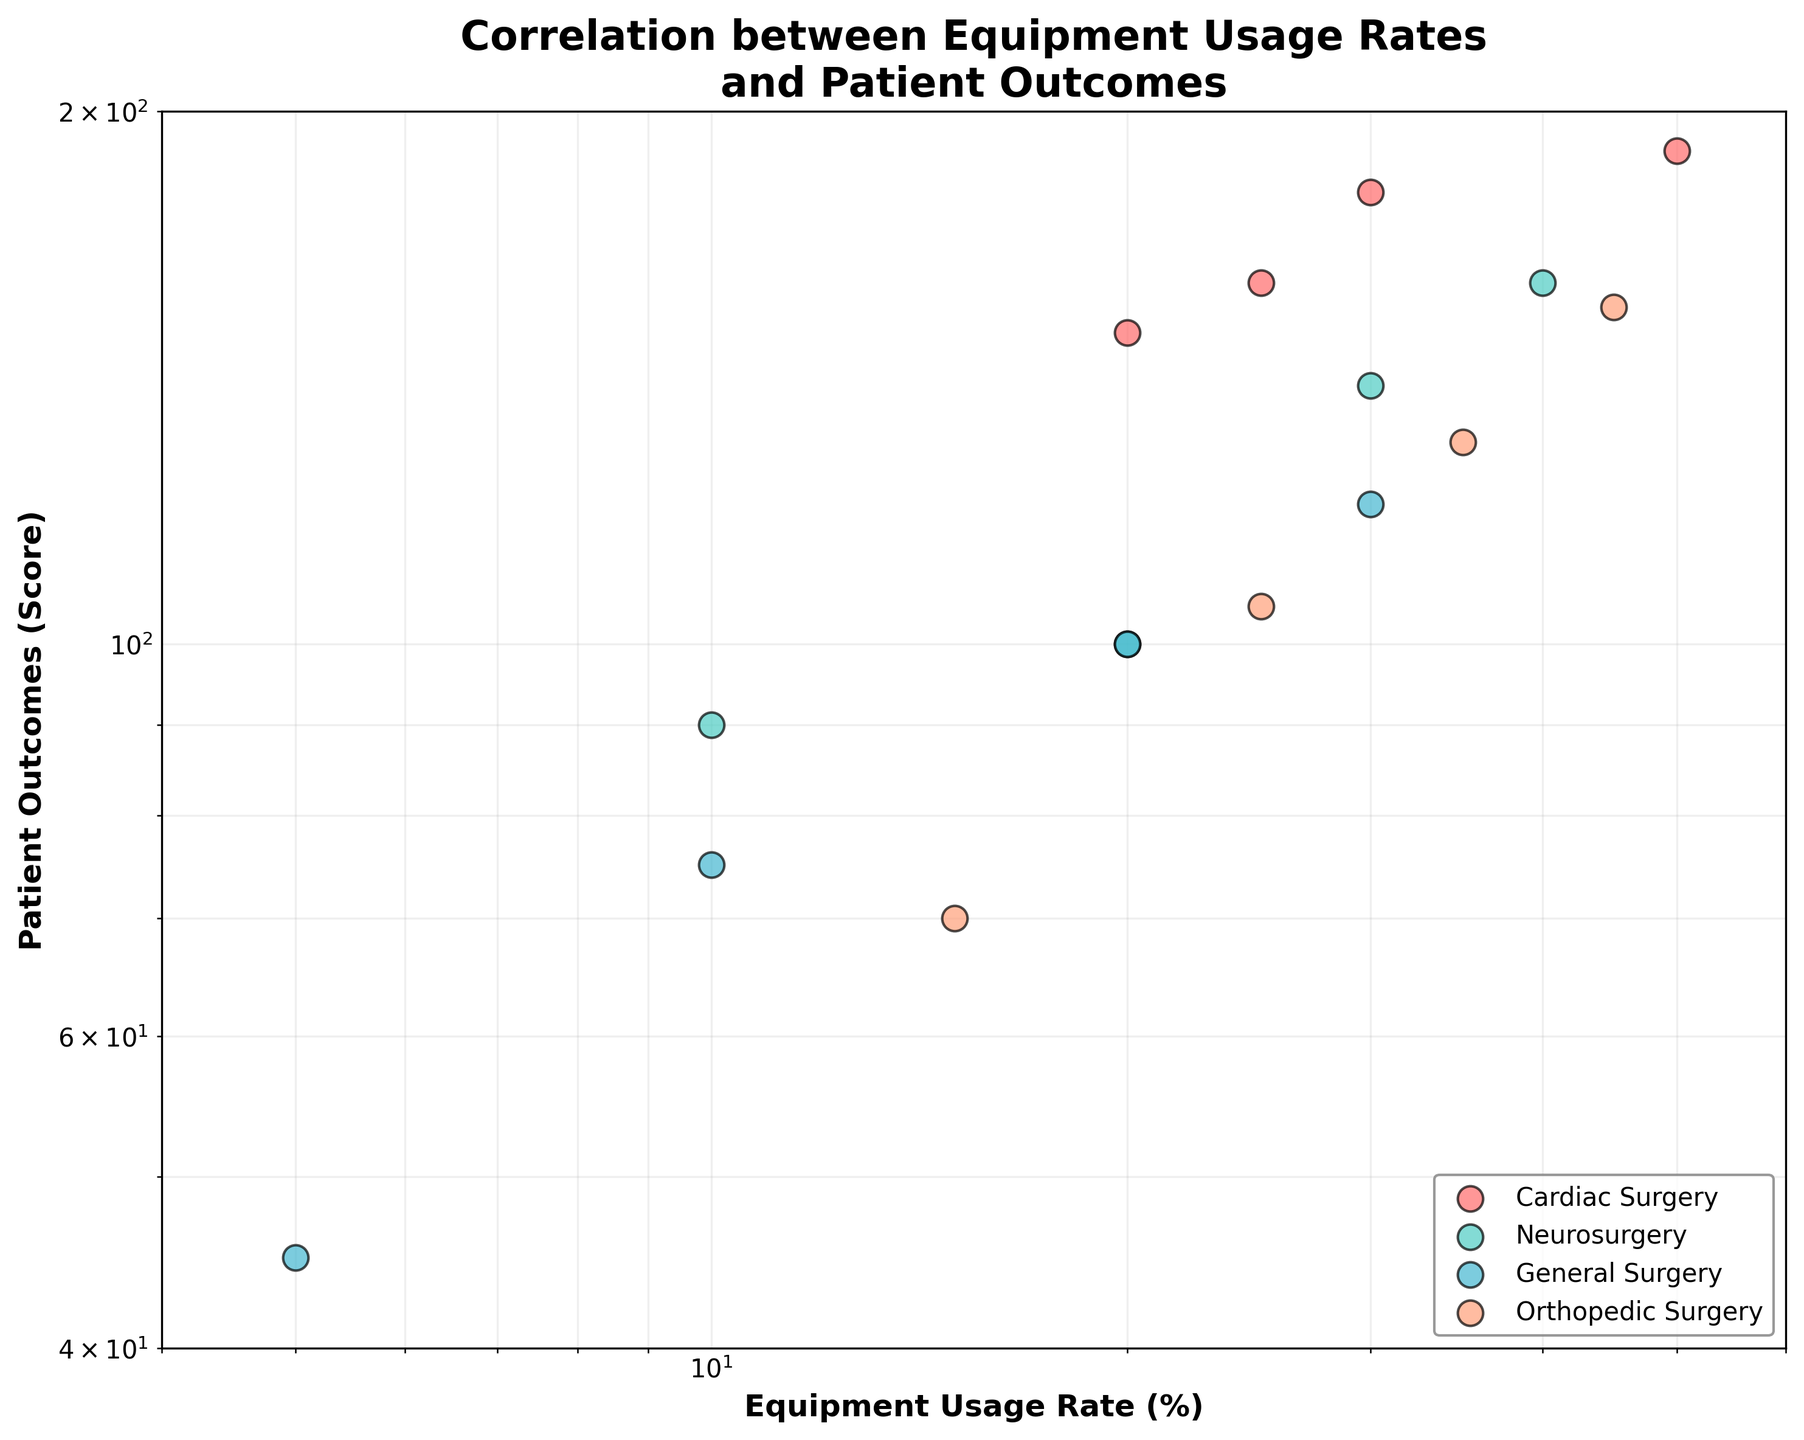What is the title of the plot? The title is displayed at the top of the plot, combining information about equipment usage rates and patient outcomes in different surgical units.
Answer: Correlation between Equipment Usage Rates and Patient Outcomes How many surgical units are represented in the plot? Each unique color and label in the legend represent a different surgical unit. By counting them, we can determine the total number of units.
Answer: Four Which surgical unit has the highest patient outcome at the maximum equipment usage rate? By examining the data points furthest to the right on the x-axis (highest equipment usage rate) and looking at their corresponding y-values (patient outcomes), we can identify the unit.
Answer: Cardiac Surgery Which unit shows the least amount of variation in patient outcomes across different equipment usage rates? Compare the spread of patient outcomes (y-axis values) for each unit. Units with points close together show less variation.
Answer: Orthopedic Surgery What is the relationship between equipment usage rates and patient outcomes in general? The plot uses a log-log scale, making it easier to identify trends. For most units, as equipment usage rates increase, so do patient outcomes.
Answer: Positive correlation How does the performance of Neurosurgery compare with General Surgery at the 20% equipment usage rate? Locate the points for both Neurosurgery and General Surgery at 20% equipment usage rate on the x-axis and compare their y-values.
Answer: Neurosurgery has higher outcomes What is the range of patient outcomes for Orthopedic Surgery? Identify the highest and lowest y-values for Orthopedic Surgery and subtract them to find the range.
Answer: 85 Which unit has the steepest improvement in patient outcomes with increasing equipment usage rates? Units with data points showing rapid upward movement on the y-axis with increasing x-values indicate a steep improvement. Compare slopes visually.
Answer: Cardiac Surgery If an average surgical unit has a 25% equipment usage rate, approximately what are the expected patient outcomes for Neurosurgery and Orthopedic Surgery? Locate the points on the plot for Neurosurgery and Orthopedic Surgery at 25% equipment usage rate on the x-axis and approximate their y-values.
Answer: Neurosurgery: ~100, Orthopedic Surgery: ~105 